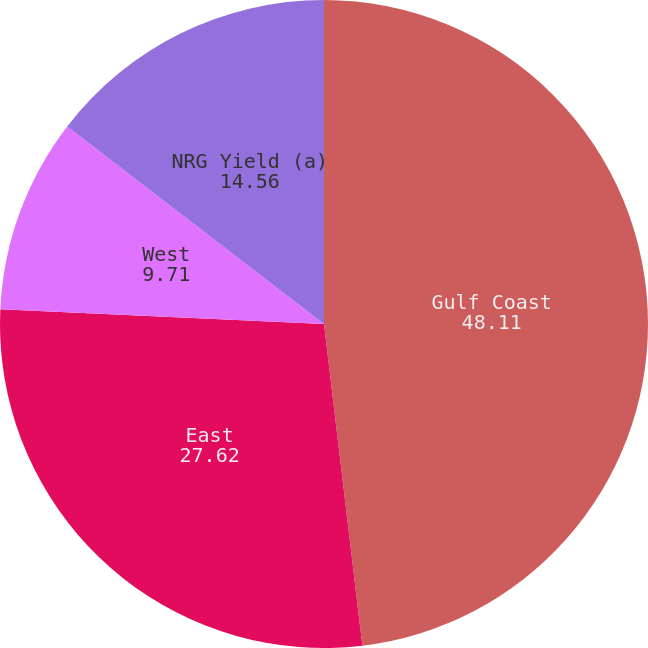Convert chart to OTSL. <chart><loc_0><loc_0><loc_500><loc_500><pie_chart><fcel>Gulf Coast<fcel>East<fcel>West<fcel>NRG Yield (a)<nl><fcel>48.11%<fcel>27.62%<fcel>9.71%<fcel>14.56%<nl></chart> 